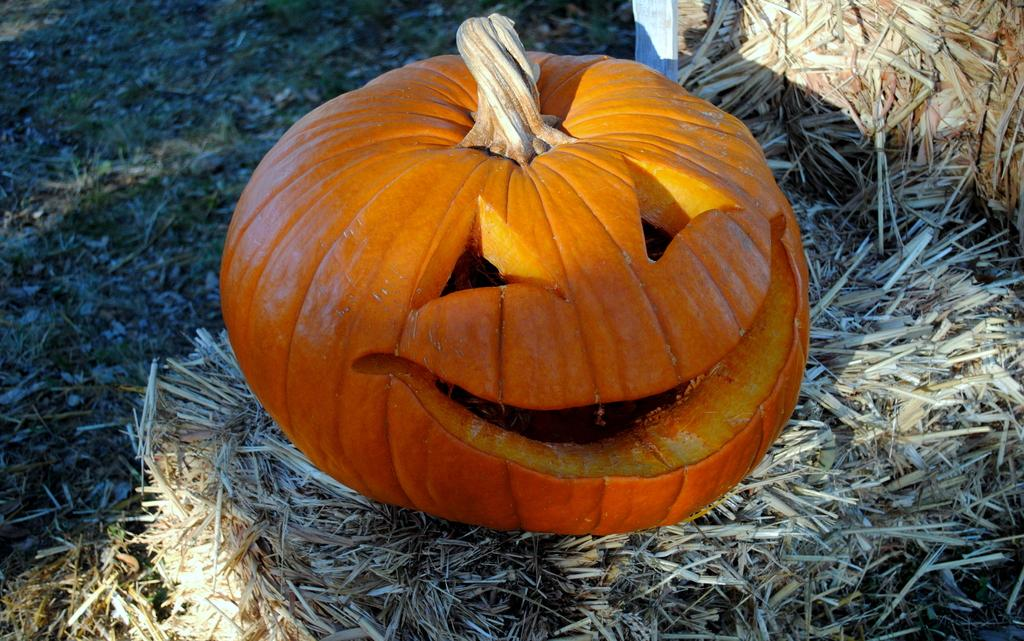What type of vegetation can be seen in the image? There is dry grass in the image. What object is placed on the dry grass? There is an orange-colored pumpkin on the dry grass. What type of sugar can be seen in the image? There is no sugar present in the image; it features dry grass and an orange-colored pumpkin. 